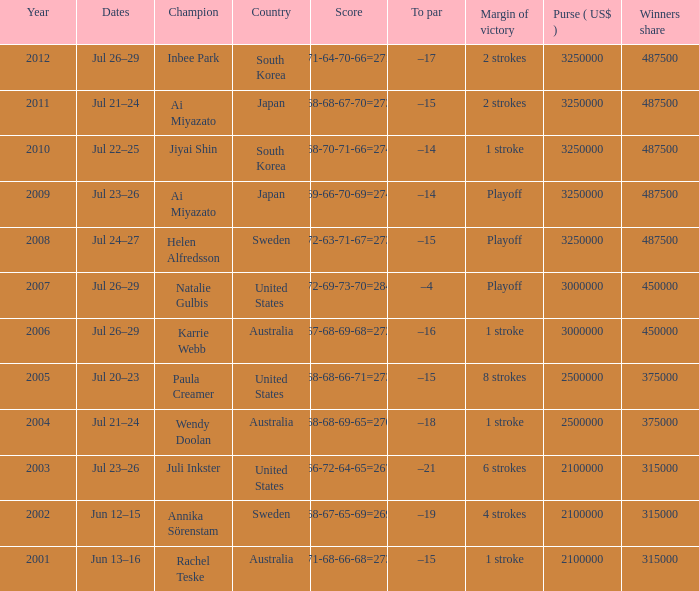At what date is the score 66-72-64-65=267? Jul 23–26. 